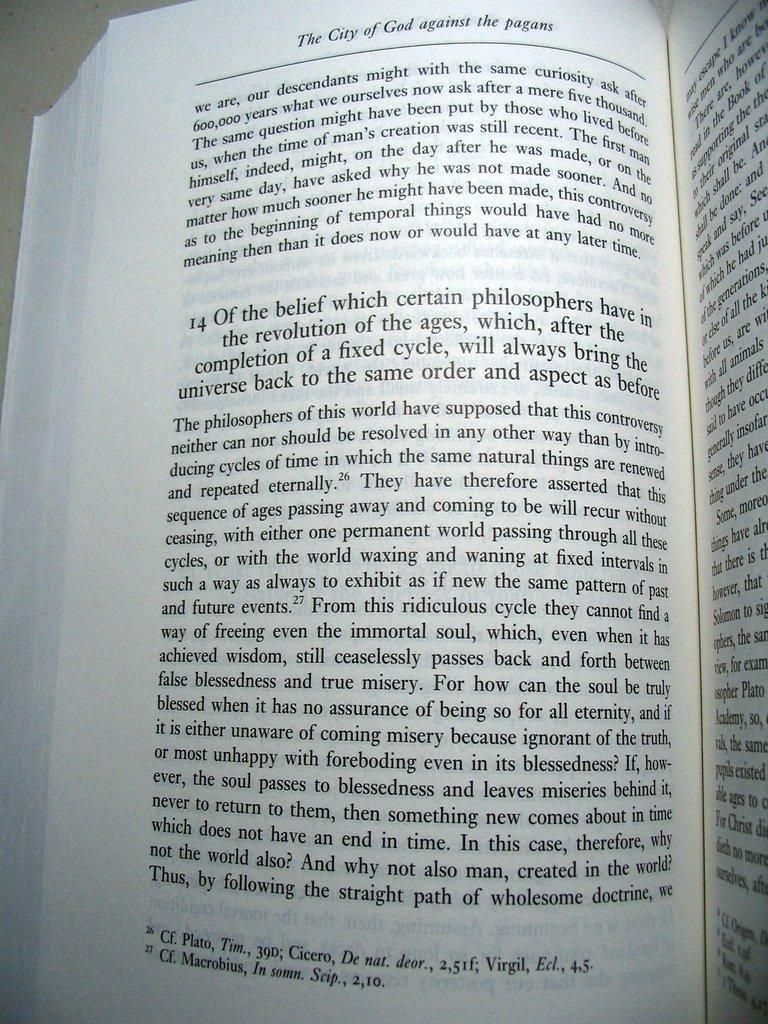<image>
Provide a brief description of the given image. A book is open, the title The City of God against the pagans in italic at the top. 